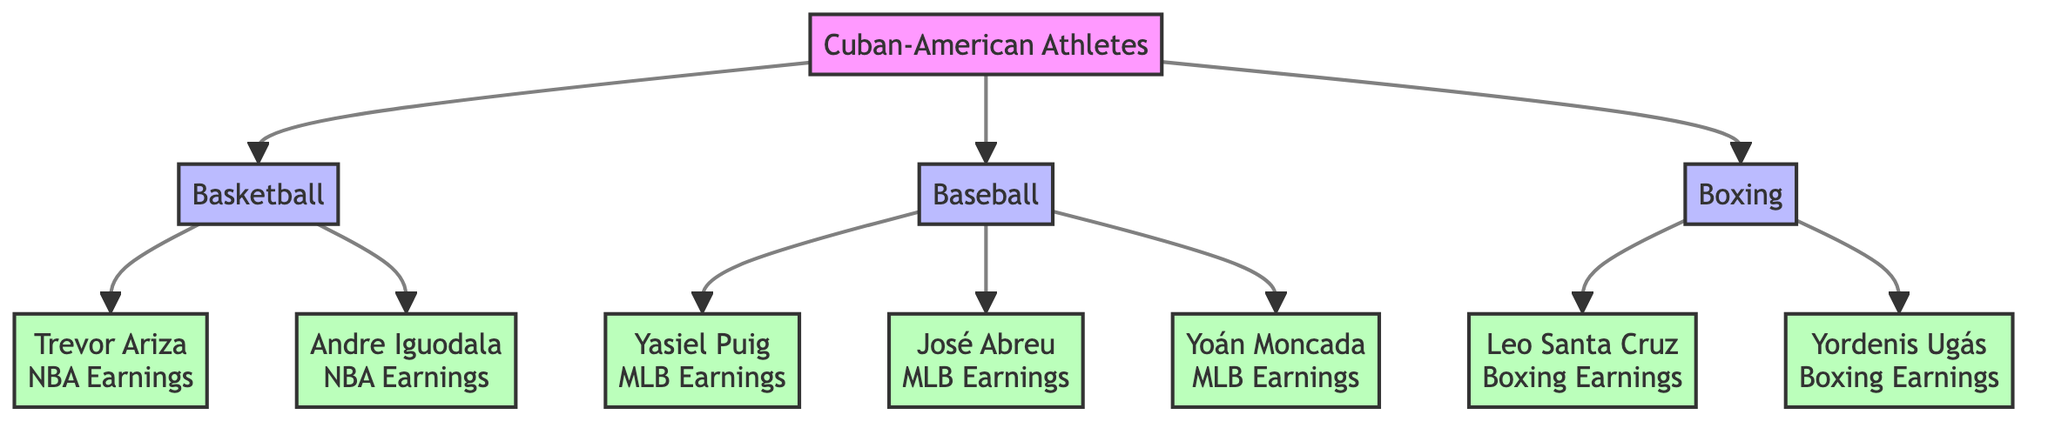What's the total number of sports represented in the diagram? The diagram outlines three distinct sports: Basketball, Baseball, and Boxing. Each sport branches from the main node representing Cuban-American athletes.
Answer: 3 Which athlete has NBA earnings listed in the diagram? The diagram lists two athletes with NBA earnings: Trevor Ariza and Andre Iguodala, which can be found as branches under the Basketball node.
Answer: Trevor Ariza, Andre Iguodala How many MLB athletes are mentioned in the diagram? The Baseball section features three athletes: Yasiel Puig, José Abreu, and Yoán Moncada. This counts as three distinct nodes under the Baseball category.
Answer: 3 Which sport has the least number of athletes included in the diagram? Boxing only includes two athletes: Leo Santa Cruz and Yordenis Ugás. Comparing this to three athletes in Baseball and Basketball, Boxing has the fewest, making it the sport with the least number of athletes represented.
Answer: Boxing Who earns the most in MLB according to the diagram? To determine the highest earning MLB athlete, we need to analyze the athletes listed under the Baseball node, which are Yasiel Puig, José Abreu, and Yoán Moncada. However, specific numerical values aren't provided, so a direct answer cannot be inferred, but José Abreu could be inferred as a prominent figure in discussions on MLB earnings.
Answer: José Abreu (implied) What is the relationship between Basketball and Cuban-American athletes? The diagram shows that Basketball is one of the three sports that Cuban-American athletes participate in, directly connecting Basketball to the Cuban-American Athletes node, signifying both sports as a platform for their earnings.
Answer: Basketball is connected to Cuban-American athletes Who earns the least in Boxing according to the diagram? The diagram shows two athletes in boxing: Leo Santa Cruz and Yordenis Ugás. Without specific earnings provided, it's ambiguous which of the two has lower earnings based on the information presented. Thus, I cannot definitively say who earns the least.
Answer: Cannot determine from the diagram How many athlete nodes are connected to Baseball? Under the Baseball node, there are three athlete nodes connected: Yasiel Puig, José Abreu, and Yoán Moncada. This number is directly countable from the branches stemming from the Baseball node.
Answer: 3 